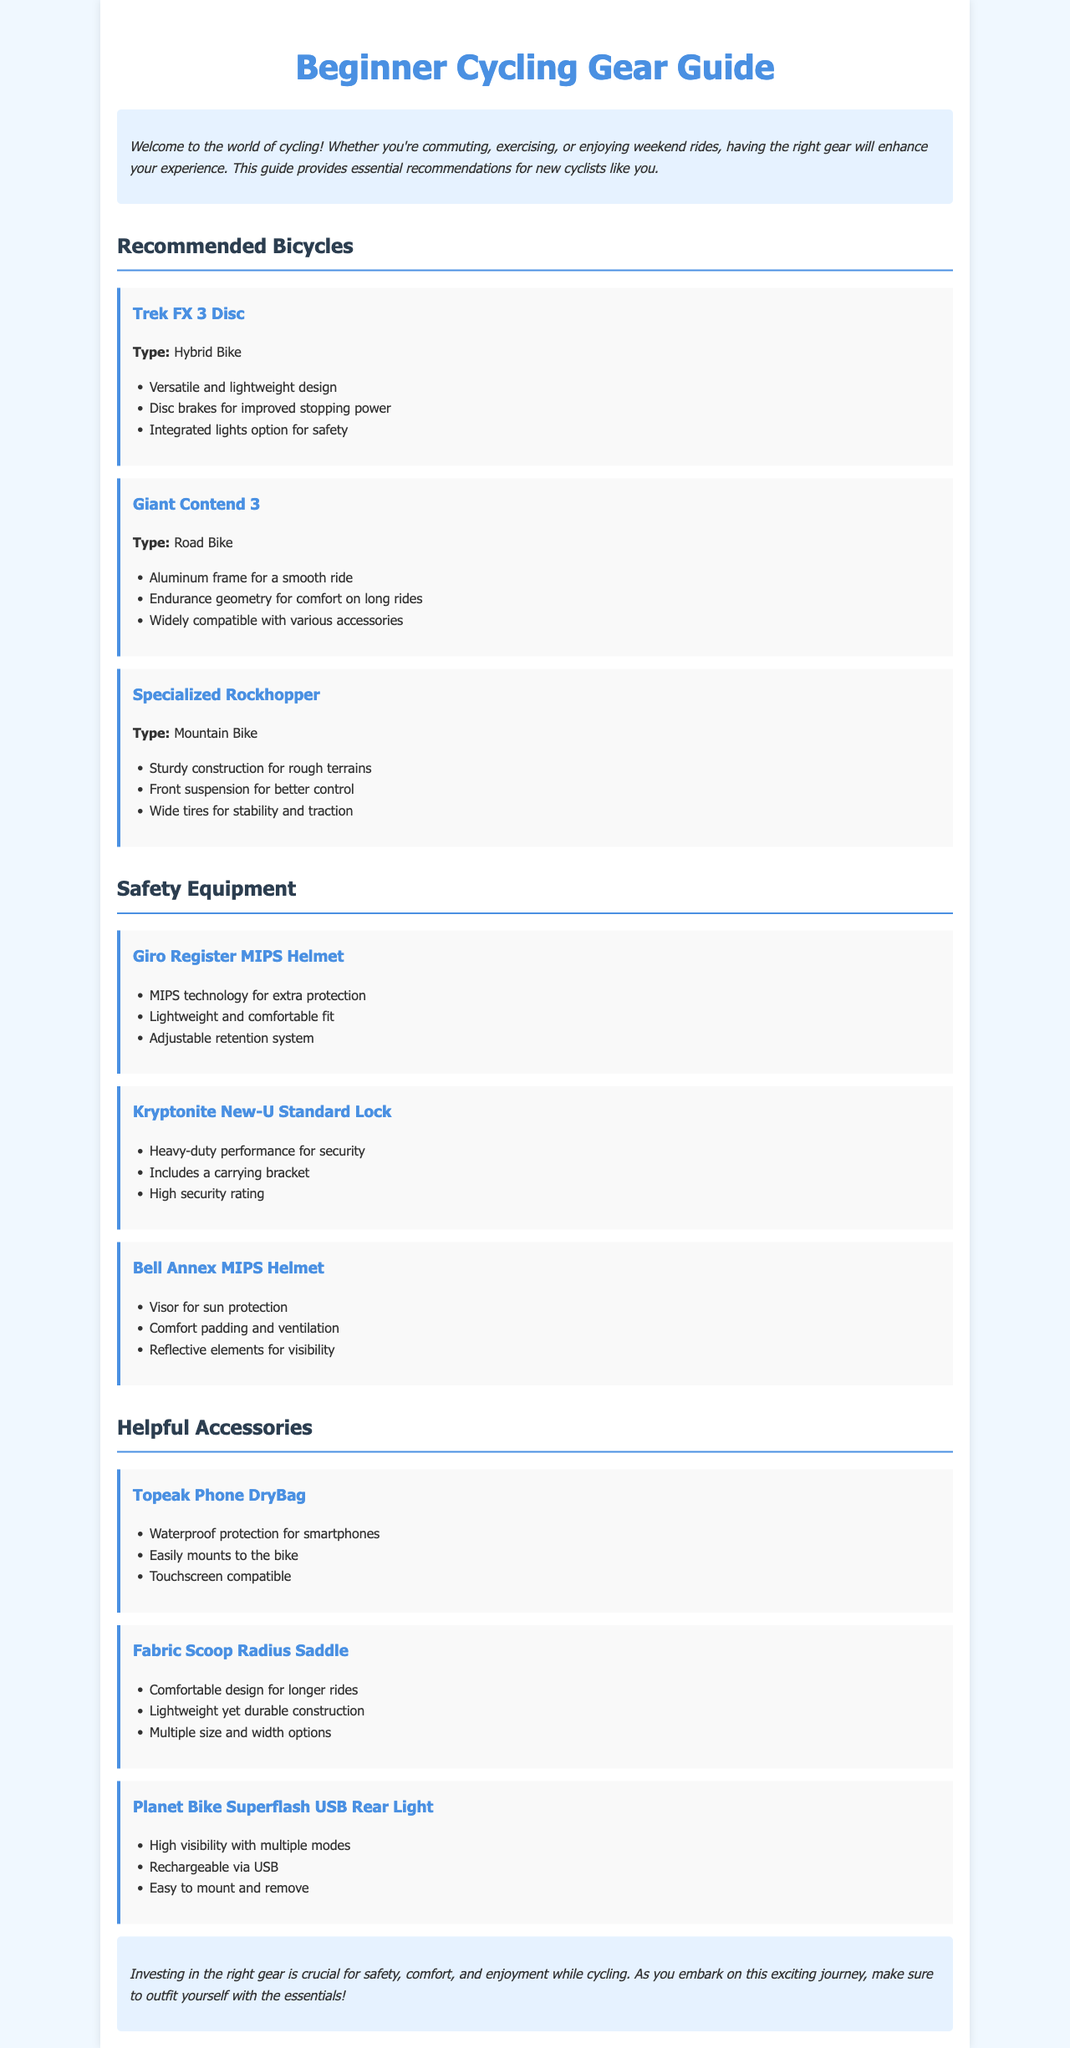What is the title of the guide? The title of the guide is clearly stated at the top of the document.
Answer: Beginner Cycling Gear Guide How many recommended bicycles are listed in the guide? The document lists three bicycles in the recommended bicycles section.
Answer: 3 What type of bike is the Trek FX 3 Disc? The document specifies the type of the Trek FX 3 Disc bike in the recommended section.
Answer: Hybrid Bike What safety equipment features MIPS technology? The document states that the Giro Register MIPS Helmet includes MIPS technology for extra protection.
Answer: Giro Register MIPS Helmet Which accessory is waterproof? The document describes the Topeak Phone DryBag as providing waterproof protection for smartphones.
Answer: Topeak Phone DryBag What color is the heading for the introduction section? The document states that the introduction section has a specific background color.
Answer: Light blue What is one characteristic of the Giant Contend 3's frame? The document mentions that the Giant Contend 3 features a specific type of frame.
Answer: Aluminum frame How is the Planet Bike Superflash USB Rear Light powered? The document provides information on how the rear light is charged.
Answer: Rechargeable via USB 